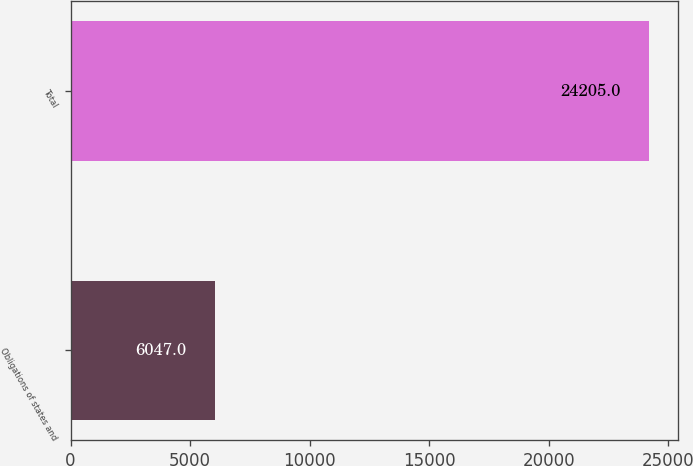<chart> <loc_0><loc_0><loc_500><loc_500><bar_chart><fcel>Obligations of states and<fcel>Total<nl><fcel>6047<fcel>24205<nl></chart> 